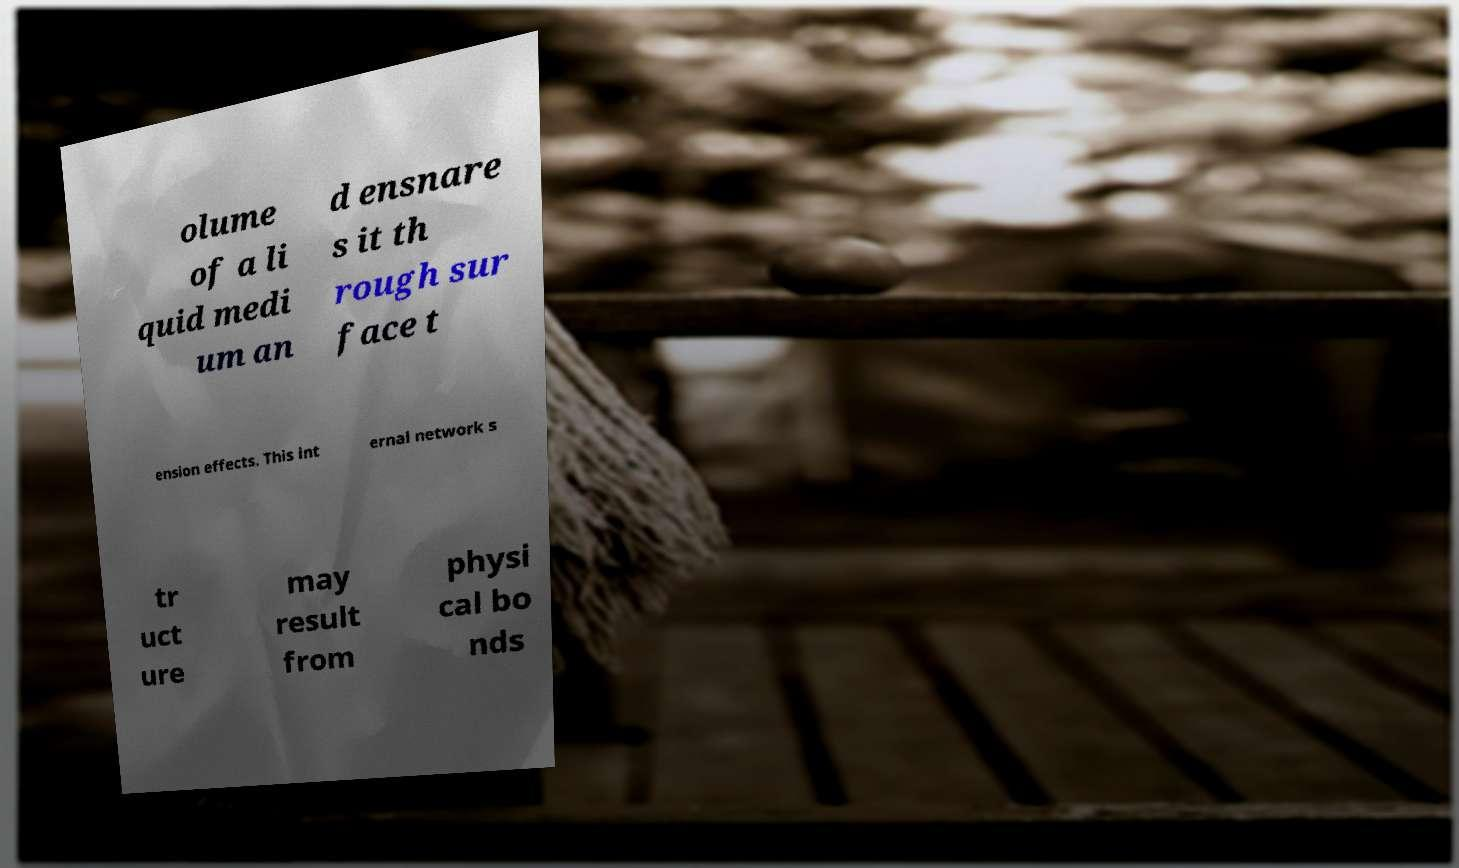There's text embedded in this image that I need extracted. Can you transcribe it verbatim? olume of a li quid medi um an d ensnare s it th rough sur face t ension effects. This int ernal network s tr uct ure may result from physi cal bo nds 